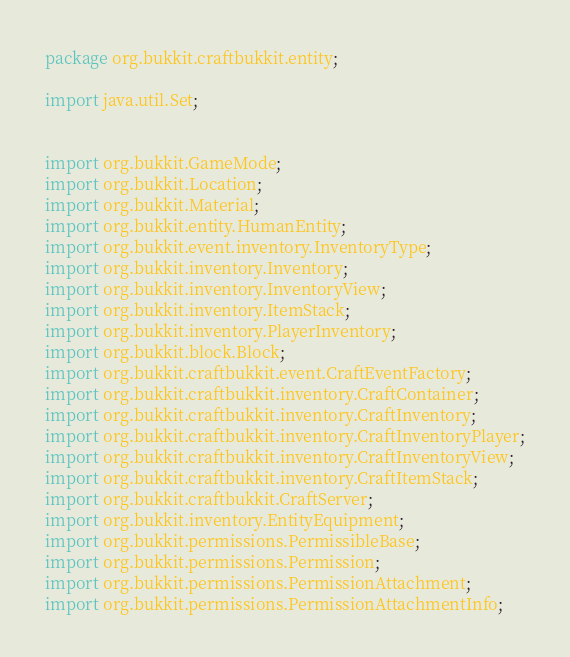<code> <loc_0><loc_0><loc_500><loc_500><_Java_>package org.bukkit.craftbukkit.entity;

import java.util.Set;


import org.bukkit.GameMode;
import org.bukkit.Location;
import org.bukkit.Material;
import org.bukkit.entity.HumanEntity;
import org.bukkit.event.inventory.InventoryType;
import org.bukkit.inventory.Inventory;
import org.bukkit.inventory.InventoryView;
import org.bukkit.inventory.ItemStack;
import org.bukkit.inventory.PlayerInventory;
import org.bukkit.block.Block;
import org.bukkit.craftbukkit.event.CraftEventFactory;
import org.bukkit.craftbukkit.inventory.CraftContainer;
import org.bukkit.craftbukkit.inventory.CraftInventory;
import org.bukkit.craftbukkit.inventory.CraftInventoryPlayer;
import org.bukkit.craftbukkit.inventory.CraftInventoryView;
import org.bukkit.craftbukkit.inventory.CraftItemStack;
import org.bukkit.craftbukkit.CraftServer;
import org.bukkit.inventory.EntityEquipment;
import org.bukkit.permissions.PermissibleBase;
import org.bukkit.permissions.Permission;
import org.bukkit.permissions.PermissionAttachment;
import org.bukkit.permissions.PermissionAttachmentInfo;</code> 